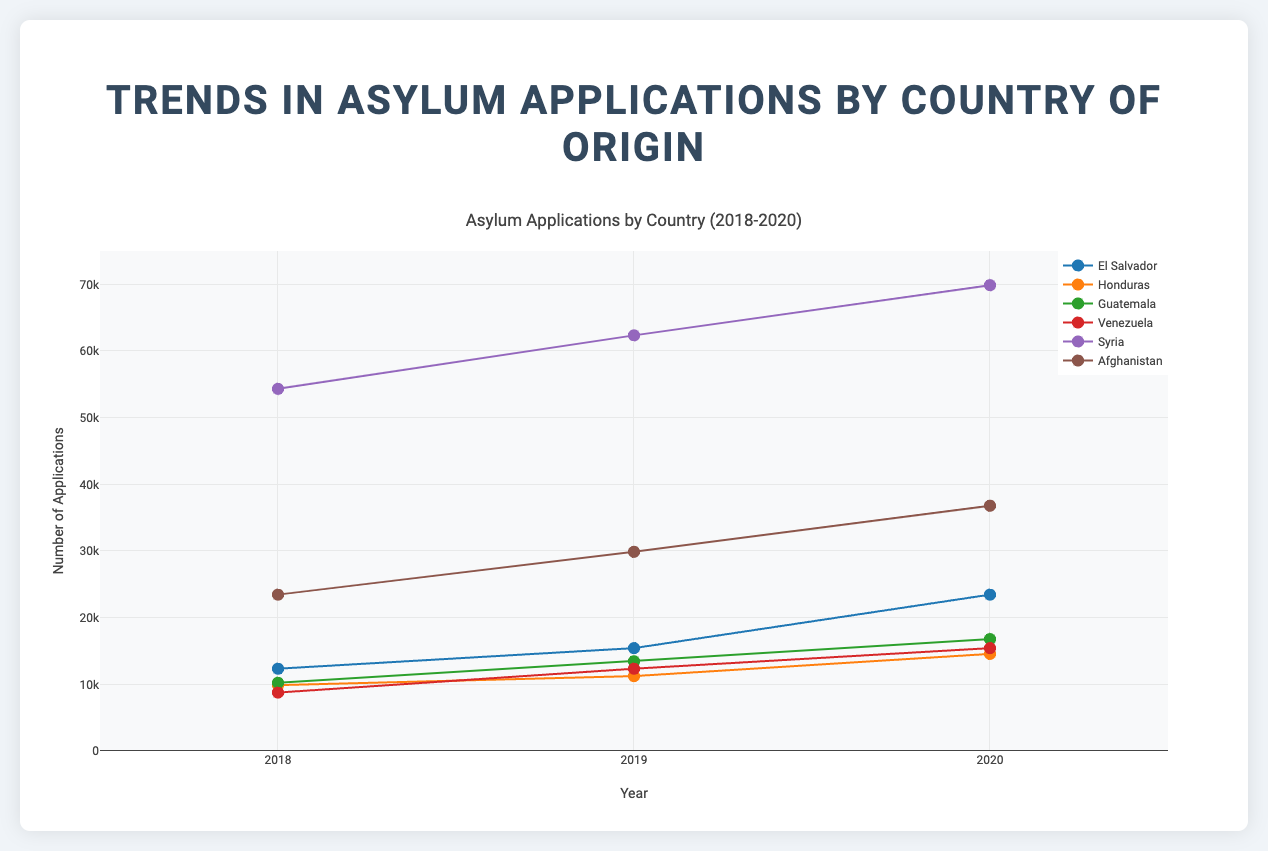What is the title of the scatter plot? The title is usually positioned at the top of the figure and summarizes the main topic of the plot. In this case, it is "Asylum Applications by Country (2018-2020)".
Answer: Asylum Applications by Country (2018-2020) Which country had the highest number of asylum applications in 2020? To find the highest number of asylum applications in 2020, look at the year 2020 on the x-axis and identify the highest point on the y-axis. From the data markers and legend, it is clear that Syria had the highest number of applications, with a value of 69876.
Answer: Syria What is the range of the y-axis? The range of the y-axis can be seen on the vertical axis, which shows the number of applications. The minimum value is 0 and the maximum value is 75000.
Answer: 0 to 75000 How many countries are represented in the scatter plot? The number of distinct lines and markers, each represented by a different color and legend entry, shows the number of countries. The legend lists six countries: El Salvador, Honduras, Guatemala, Venezuela, Syria, and Afghanistan.
Answer: 6 Which country had the largest increase in the number of asylum applications from 2018 to 2020? To determine the largest increase, subtract the number of applications in 2018 from the number in 2020 for each country. Syria's increase (69876 - 54321 = 15555) is compared with other countries:
- El Salvador: 23456 - 12345 = 11111
- Honduras: 14567 - 9876 = 4691
- Guatemala: 16789 - 10234 = 6555
- Venezuela: 15432 - 8765 = 6667
- Afghanistan: 36789 - 23456 = 13333
  
Syria has the largest increase of 15555.
Answer: Syria Between which years does the scatter plot show data? Look at the tick marks on the x-axis, which represent the years for which data points are plotted. The range of years is from 2018 to 2020.
Answer: 2018 to 2020 Did asylum applications from Venezuela increase every year? To verify this, look at the marks for Venezuela in 2018, 2019, and 2020. The numbers are 8765 in 2018, 12345 in 2019, and 15432 in 2020, indicating an increase each year.
Answer: Yes Which country's trend line shows the steepest upward trend? A steep upward trend is indicated by a sharply rising line segment. Comparing all countries, Syria's line shows the steepest increase from 2018 to 2020.
Answer: Syria What is the average number of asylum applications from Honduras over the three years? Add the number of applications for Honduras for 2018, 2019, and 2020, then divide by 3: (9876 + 11234 + 14567) / 3 = 35677 / 3 ≈ 11892.33
Answer: 11892.33 